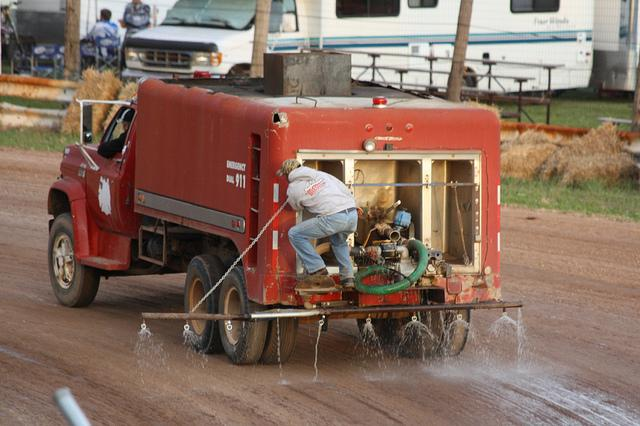How did he get on back of the truck? Please explain your reasoning. climbed on. The man hopped onto the truck. 